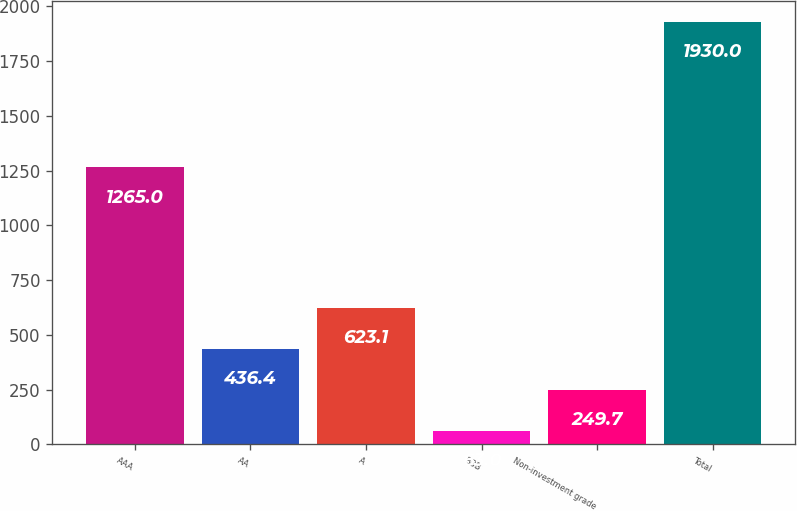<chart> <loc_0><loc_0><loc_500><loc_500><bar_chart><fcel>AAA<fcel>AA<fcel>A<fcel>BBB<fcel>Non-investment grade<fcel>Total<nl><fcel>1265<fcel>436.4<fcel>623.1<fcel>63<fcel>249.7<fcel>1930<nl></chart> 